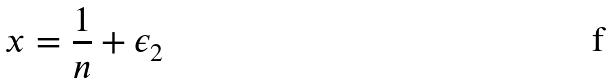Convert formula to latex. <formula><loc_0><loc_0><loc_500><loc_500>x = \frac { 1 } { n } + \epsilon _ { 2 }</formula> 